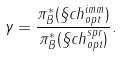<formula> <loc_0><loc_0><loc_500><loc_500>\gamma = \frac { \pi _ { B } ^ { * } ( \S c h ^ { i m m } _ { o p t } ) } { \pi _ { B } ^ { * } ( \S c h ^ { s p r } _ { o p t } ) } .</formula> 